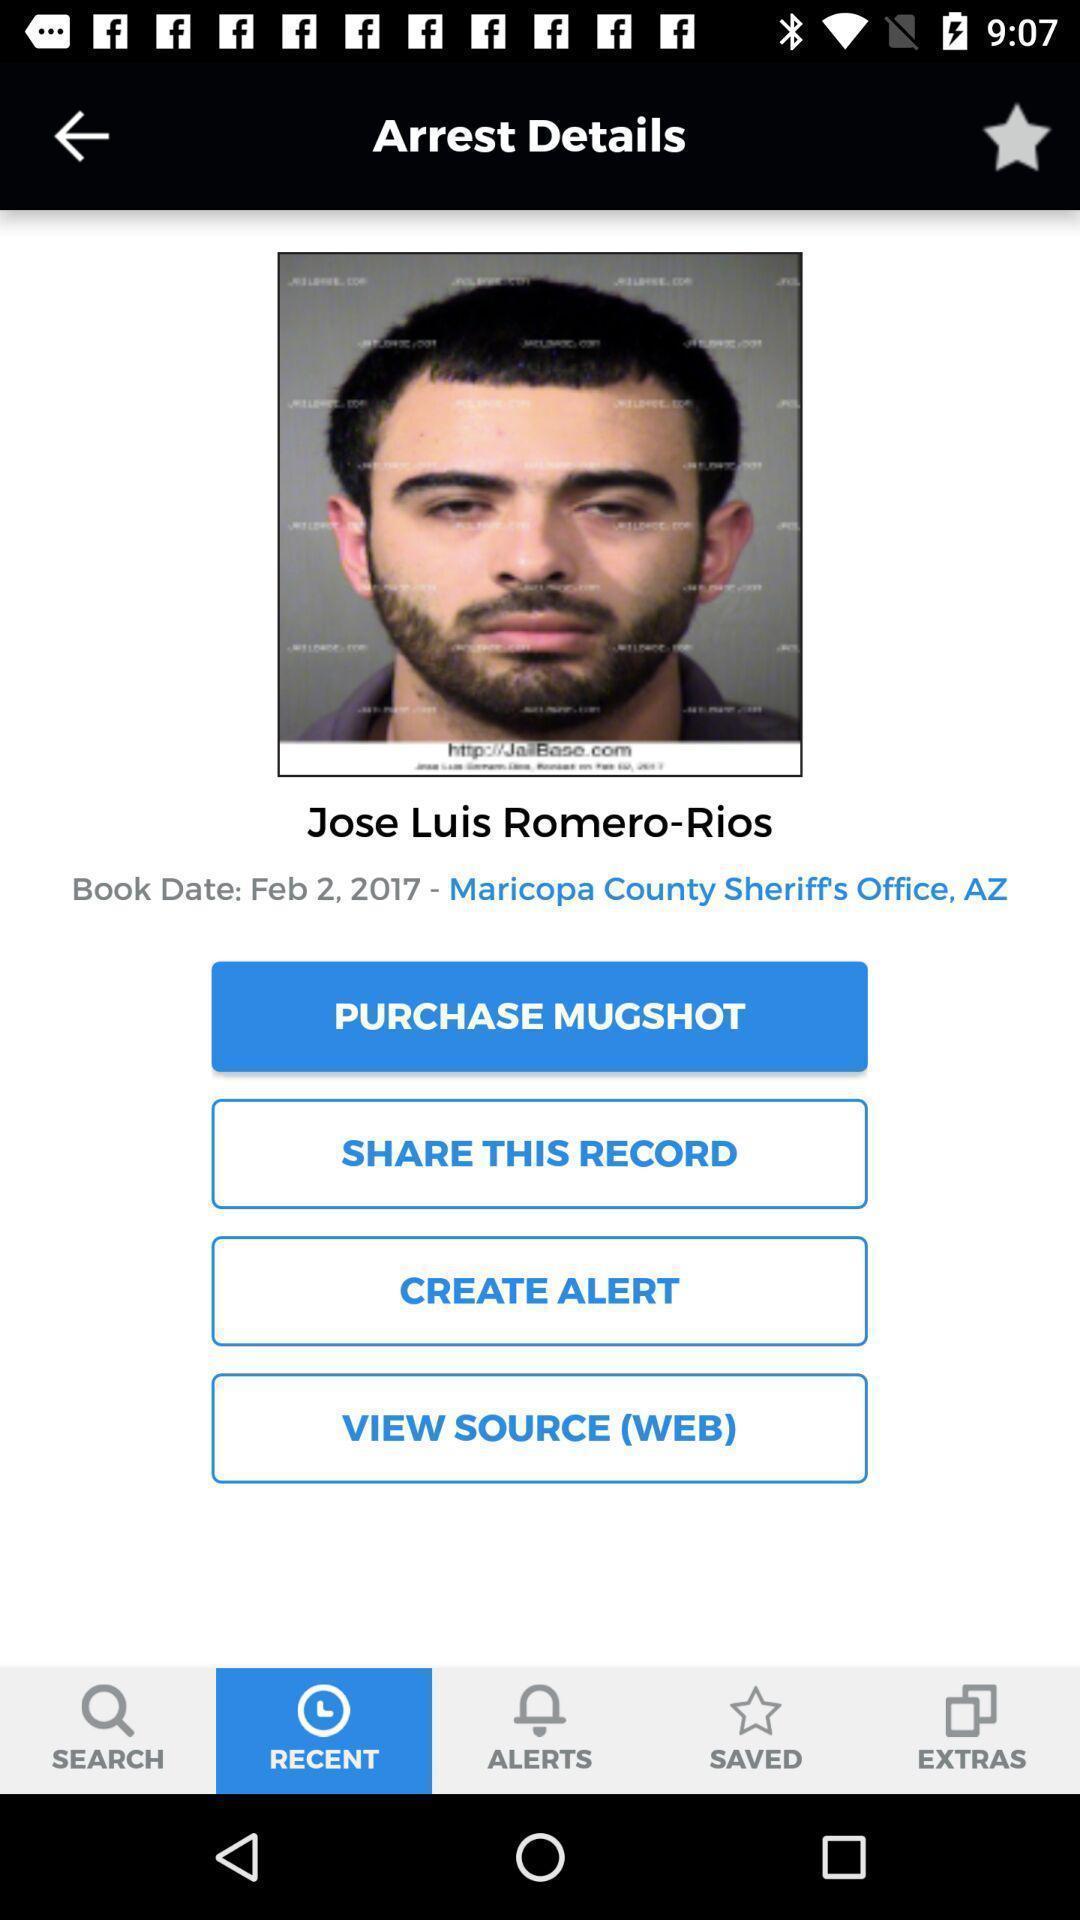Provide a description of this screenshot. Page showing a profile in an inmate database app. 